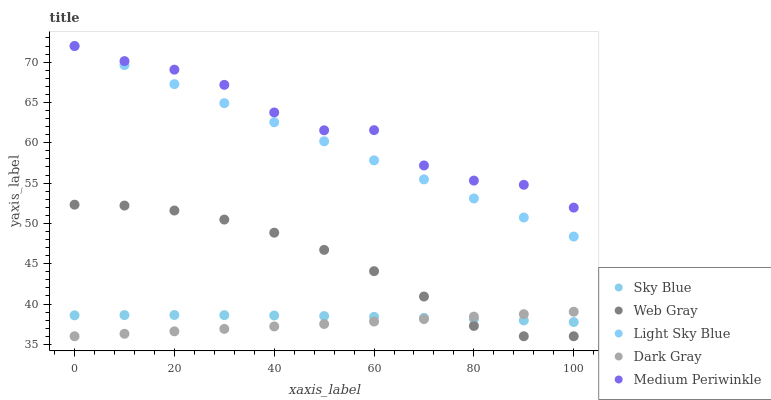Does Dark Gray have the minimum area under the curve?
Answer yes or no. Yes. Does Medium Periwinkle have the maximum area under the curve?
Answer yes or no. Yes. Does Sky Blue have the minimum area under the curve?
Answer yes or no. No. Does Sky Blue have the maximum area under the curve?
Answer yes or no. No. Is Dark Gray the smoothest?
Answer yes or no. Yes. Is Medium Periwinkle the roughest?
Answer yes or no. Yes. Is Sky Blue the smoothest?
Answer yes or no. No. Is Sky Blue the roughest?
Answer yes or no. No. Does Dark Gray have the lowest value?
Answer yes or no. Yes. Does Sky Blue have the lowest value?
Answer yes or no. No. Does Light Sky Blue have the highest value?
Answer yes or no. Yes. Does Web Gray have the highest value?
Answer yes or no. No. Is Dark Gray less than Light Sky Blue?
Answer yes or no. Yes. Is Light Sky Blue greater than Dark Gray?
Answer yes or no. Yes. Does Medium Periwinkle intersect Light Sky Blue?
Answer yes or no. Yes. Is Medium Periwinkle less than Light Sky Blue?
Answer yes or no. No. Is Medium Periwinkle greater than Light Sky Blue?
Answer yes or no. No. Does Dark Gray intersect Light Sky Blue?
Answer yes or no. No. 